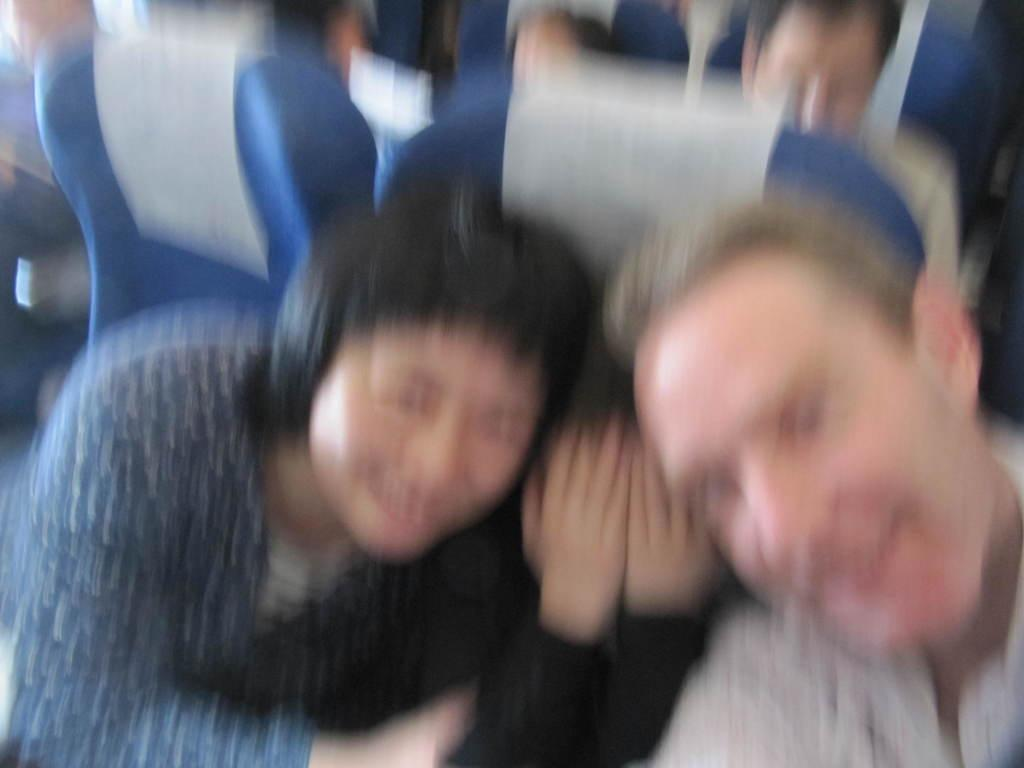How many people are in the image? There are three members in the image. Can you describe the age groups of the people in the image? Two of them are adults, and one of them is a kid. What can you tell about the seating arrangement in the image? They are sitting in blue color seats. How would you describe the quality of the image? The image is blurred. What type of payment method is being used by the kid in the image? There is no payment method visible in the image, as it features people sitting in blue color seats. 